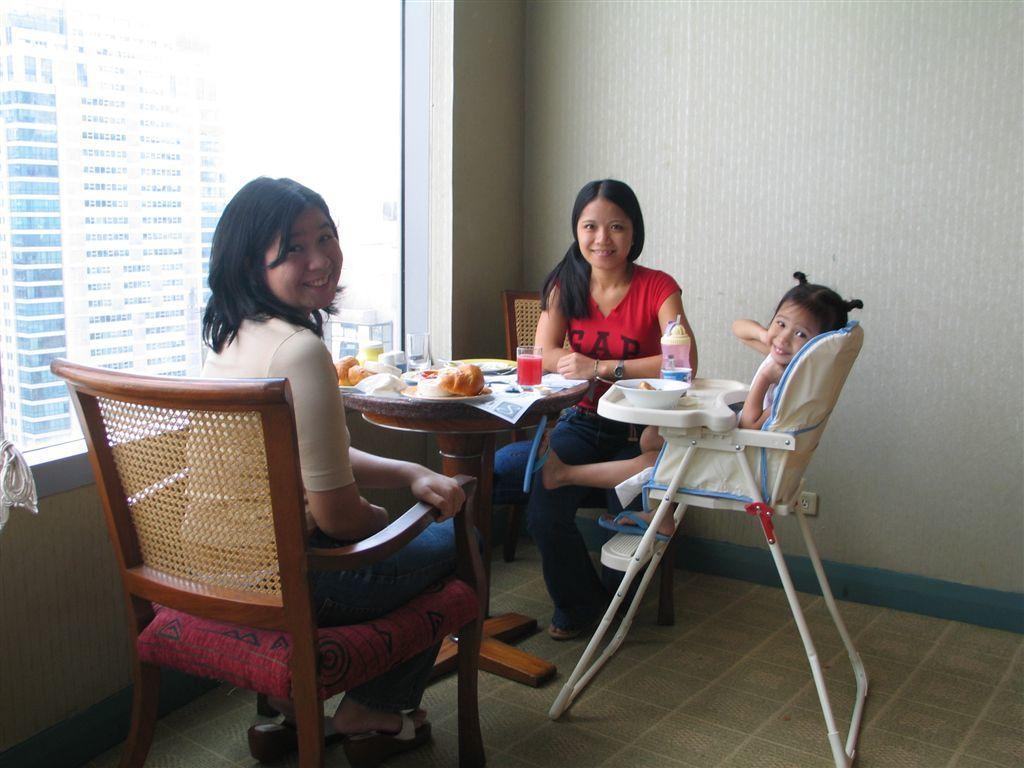Could you give a brief overview of what you see in this image? As we can see in the image there is a white color wall, a building, window and three people sitting on chairs and there is a table. On table there is a plates, glass and some food items. 